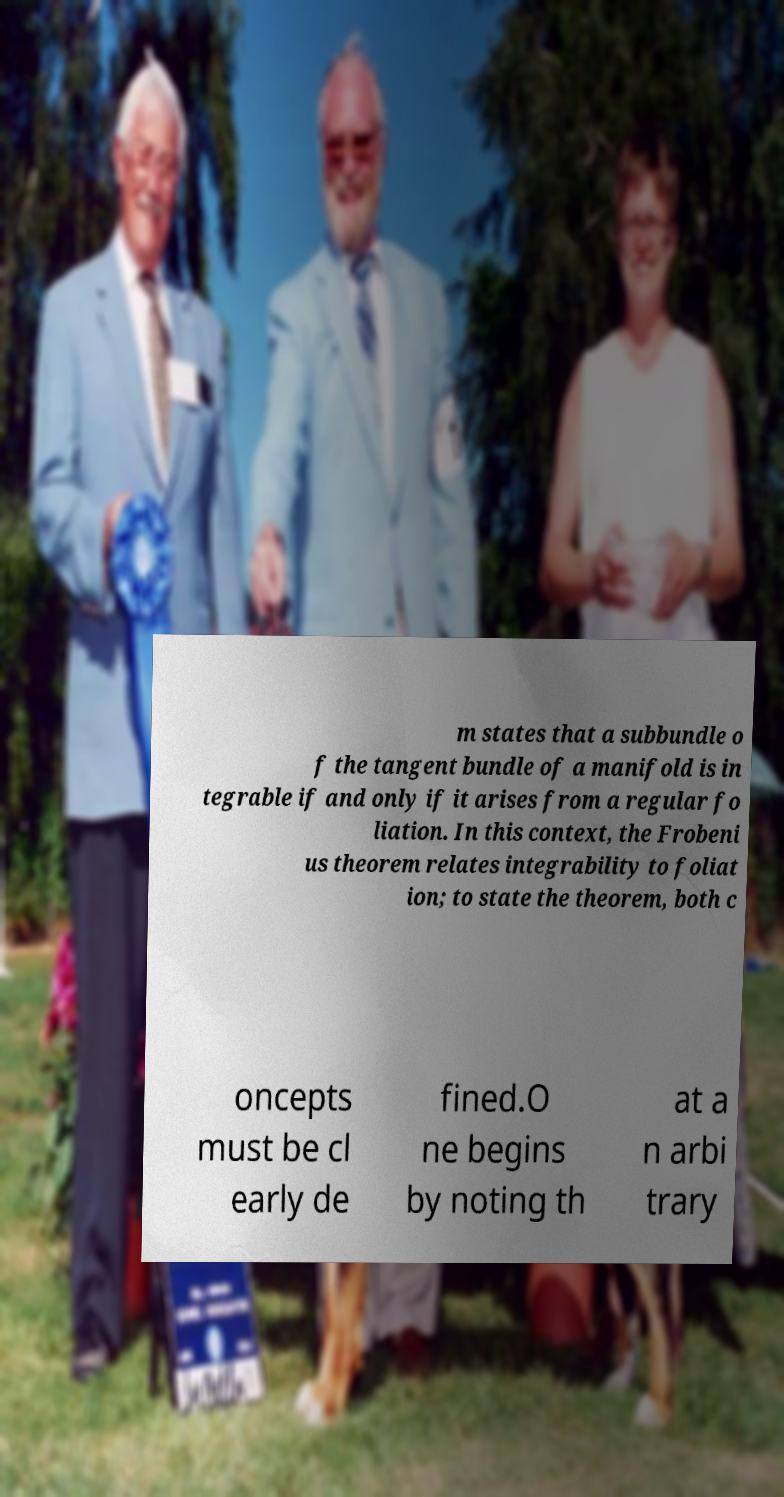What messages or text are displayed in this image? I need them in a readable, typed format. m states that a subbundle o f the tangent bundle of a manifold is in tegrable if and only if it arises from a regular fo liation. In this context, the Frobeni us theorem relates integrability to foliat ion; to state the theorem, both c oncepts must be cl early de fined.O ne begins by noting th at a n arbi trary 